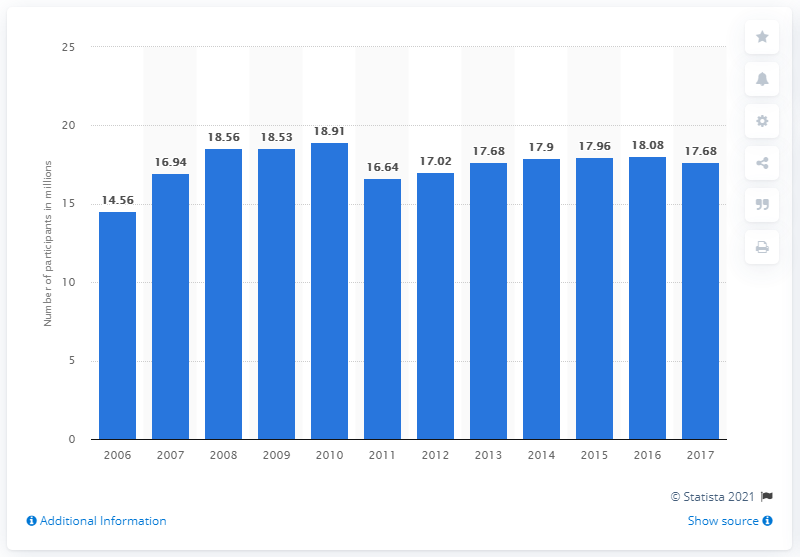Point out several critical features in this image. In 2017, the total number of tennis participants in the United States was 17.68 million. 